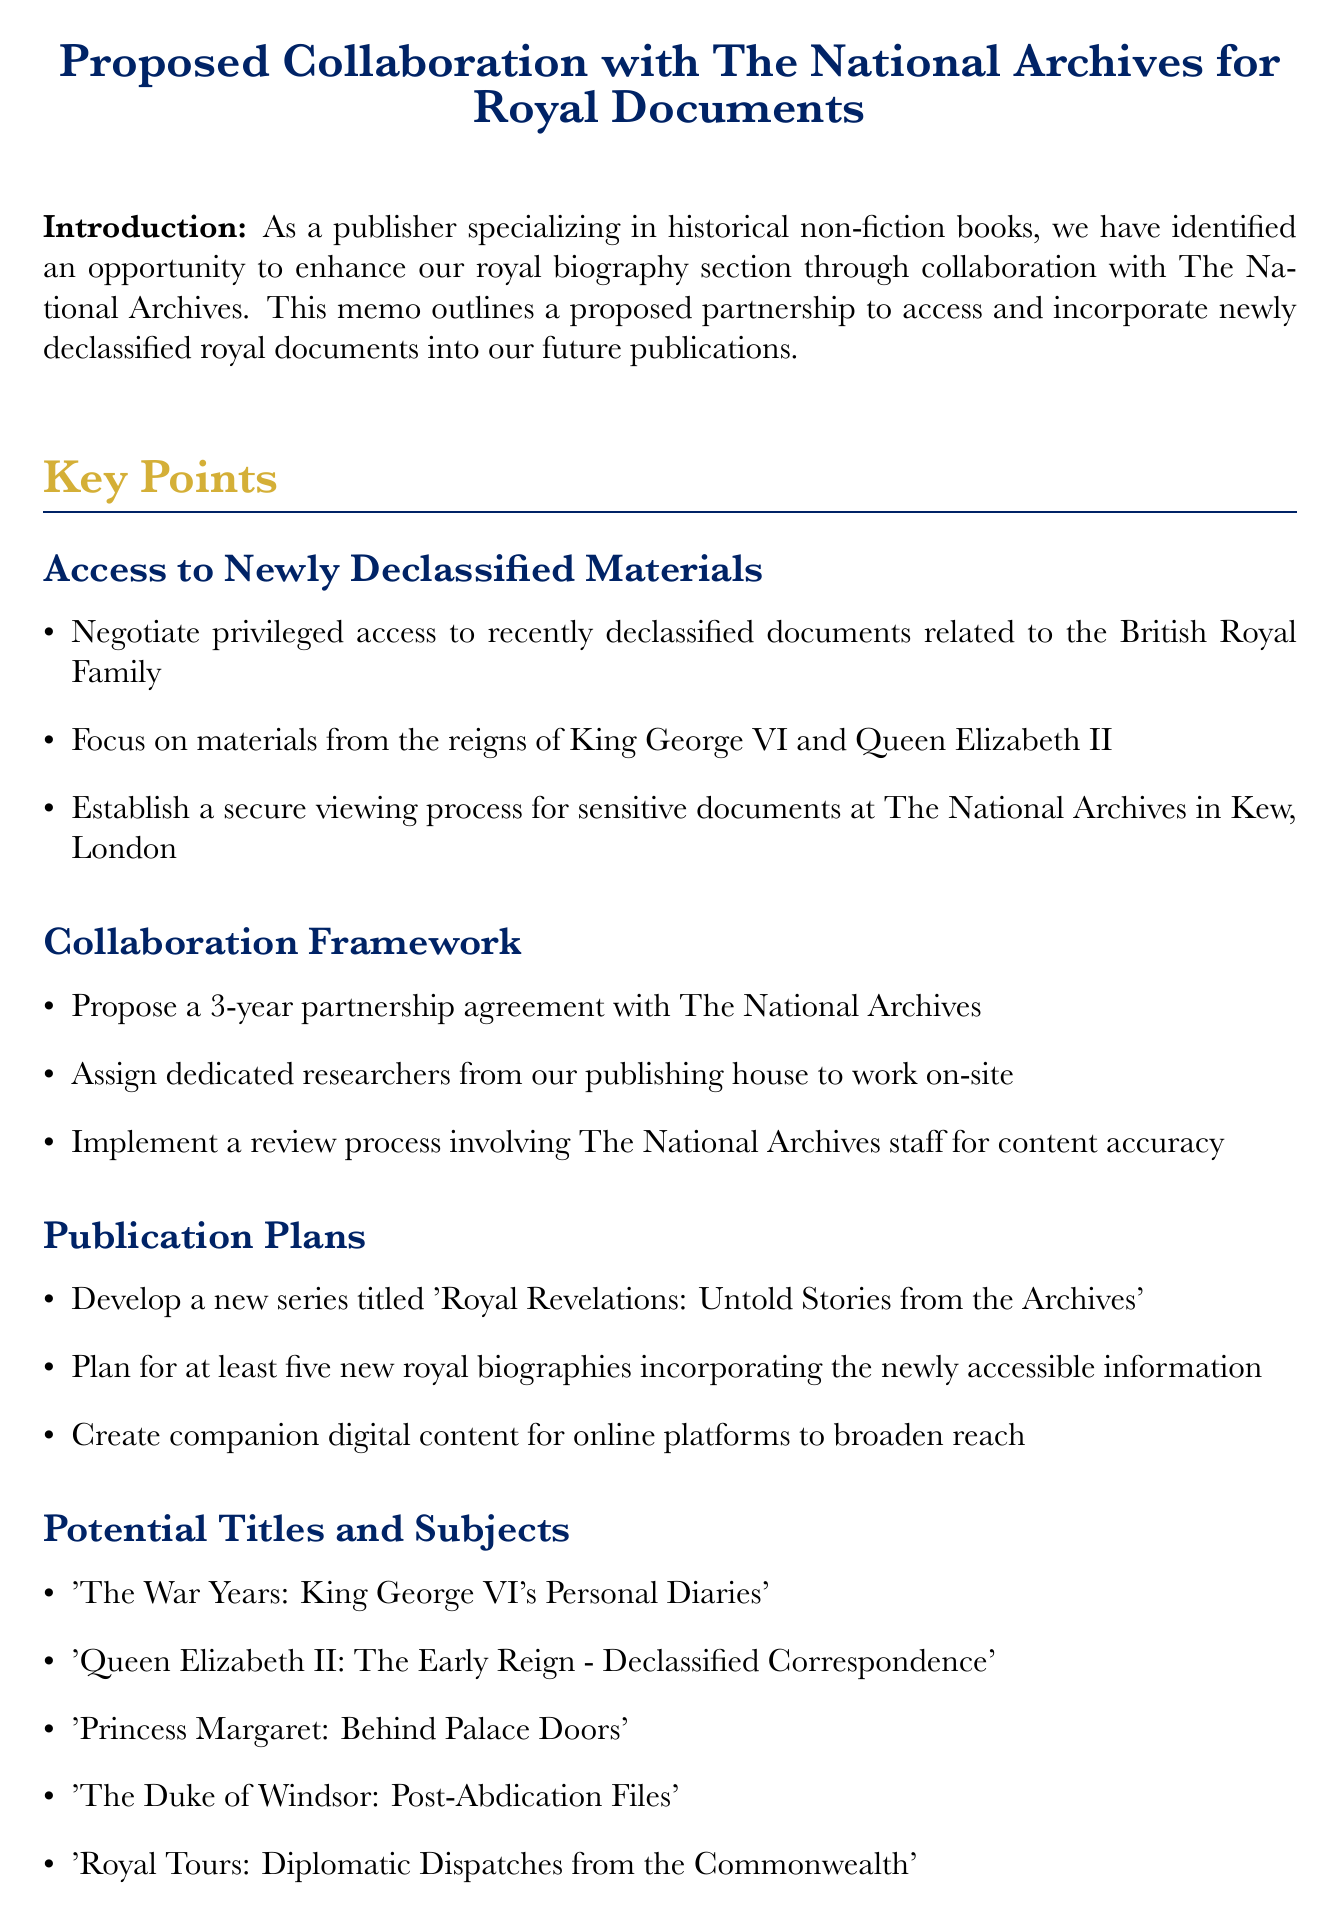What is the title of the proposed series? The title of the proposed series is mentioned under the Publication Plans section, which is 'Royal Revelations: Untold Stories from the Archives'.
Answer: Royal Revelations: Untold Stories from the Archives Who is the Chief Executive of The National Archives? The Chief Executive is mentioned in the Next Steps section as Dr. Jeff James.
Answer: Dr. Jeff James How long is the proposed partnership agreement? The duration of the proposed partnership agreement is specified as a 3-year partnership.
Answer: 3 years What is one of the potential titles listed in the memo? One of the potential titles can be found in the Potential Titles and Subjects section, such as 'The Duke of Windsor: Post-Abdication Files'.
Answer: The Duke of Windsor: Post-Abdication Files What is a key benefit of the proposed collaboration? A key benefit is listed in the Benefits section as enhanced historical accuracy and depth in our royal biographies.
Answer: Enhanced historical accuracy and depth What is one challenge mentioned in the document? One challenge provided in the Challenges and Considerations section is ensuring compliance with the Official Secrets Act.
Answer: Compliance with the Official Secrets Act What is to be prepared for the editorial board? The document indicates that a presentation outlining the project scope and potential ROI is to be prepared for the editorial board.
Answer: A presentation Which two monarchs' materials will be focused on? The specific materials mentioned in the Key Points section are from the reigns of King George VI and Queen Elizabeth II.
Answer: King George VI and Queen Elizabeth II 